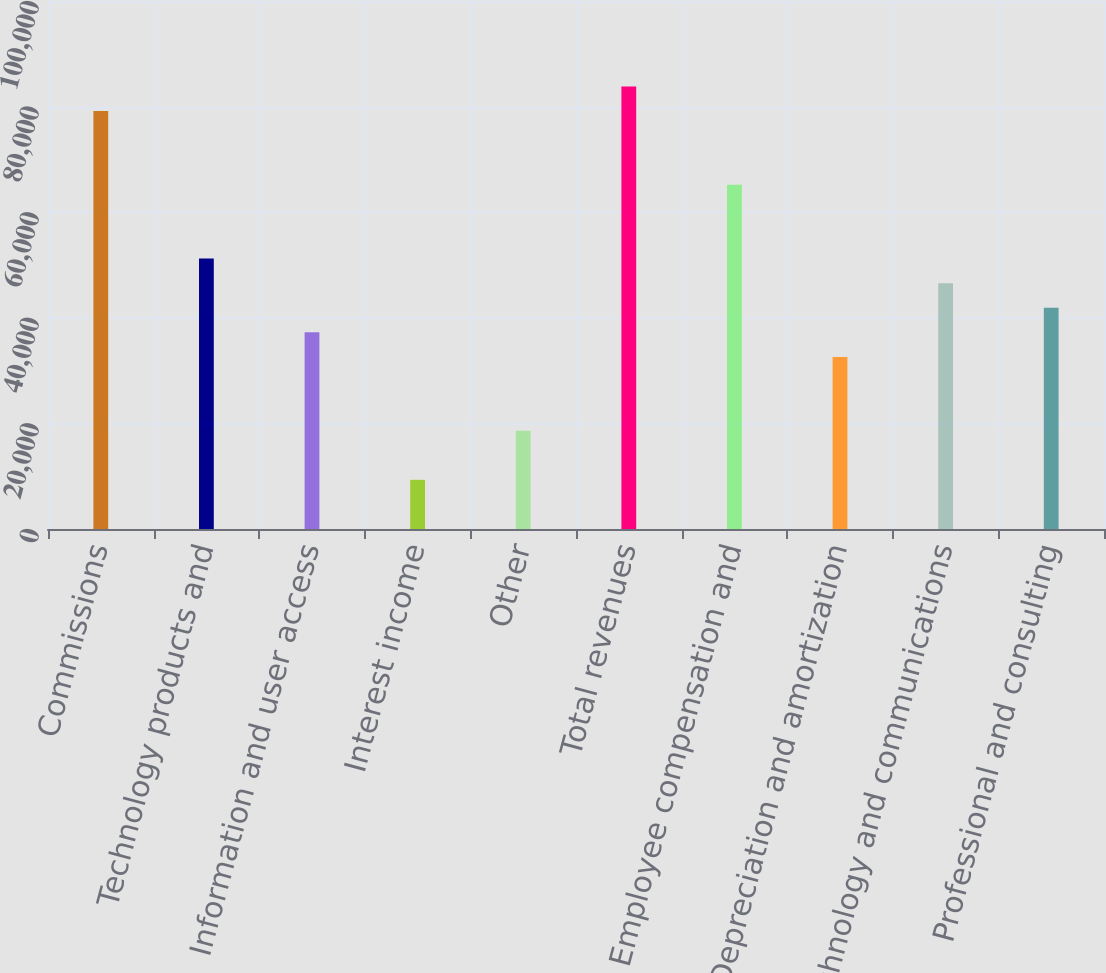Convert chart to OTSL. <chart><loc_0><loc_0><loc_500><loc_500><bar_chart><fcel>Commissions<fcel>Technology products and<fcel>Information and user access<fcel>Interest income<fcel>Other<fcel>Total revenues<fcel>Employee compensation and<fcel>Depreciation and amortization<fcel>Technology and communications<fcel>Professional and consulting<nl><fcel>79158.6<fcel>51220.4<fcel>37251.3<fcel>9313.08<fcel>18625.8<fcel>83815<fcel>65189.5<fcel>32594.9<fcel>46564<fcel>41907.7<nl></chart> 